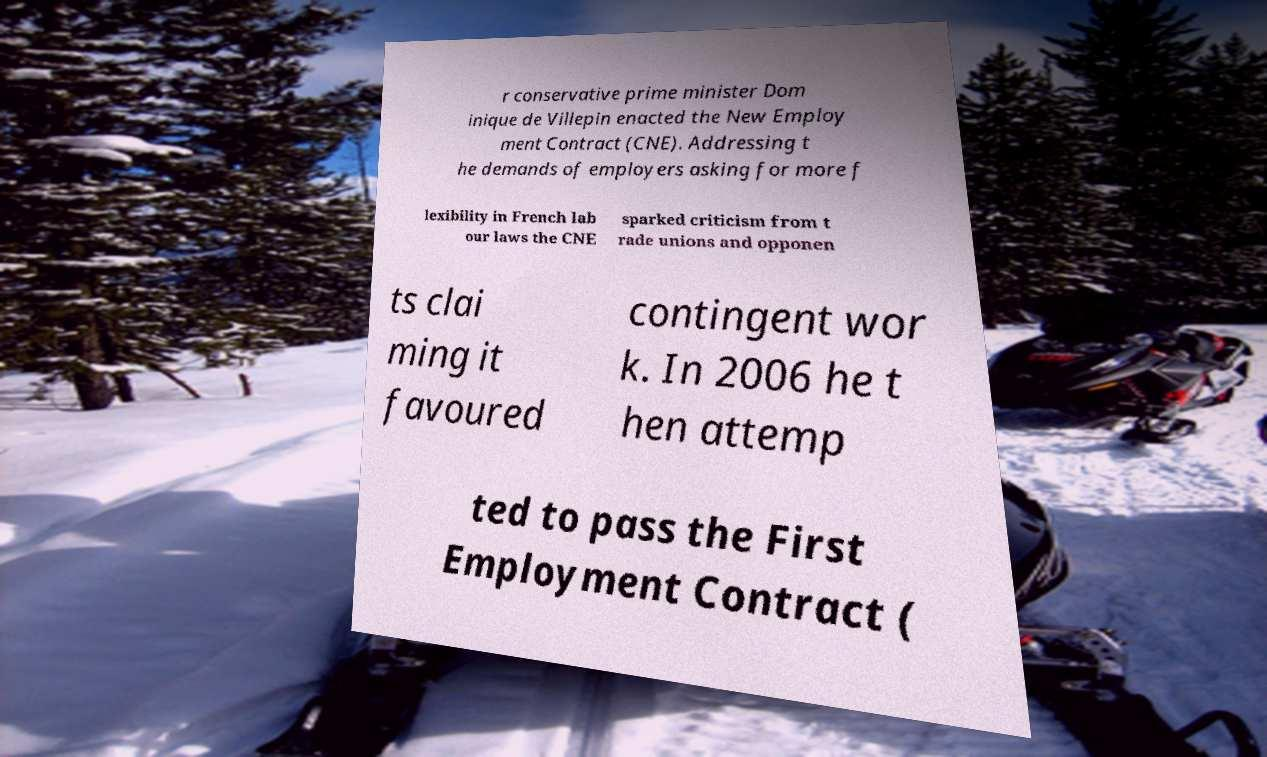For documentation purposes, I need the text within this image transcribed. Could you provide that? r conservative prime minister Dom inique de Villepin enacted the New Employ ment Contract (CNE). Addressing t he demands of employers asking for more f lexibility in French lab our laws the CNE sparked criticism from t rade unions and opponen ts clai ming it favoured contingent wor k. In 2006 he t hen attemp ted to pass the First Employment Contract ( 